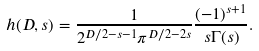<formula> <loc_0><loc_0><loc_500><loc_500>h ( D , s ) = \frac { 1 } { 2 ^ { D / 2 - s - 1 } \pi ^ { D / 2 - 2 s } } \frac { ( - 1 ) ^ { s + 1 } } { s \Gamma ( s ) } .</formula> 